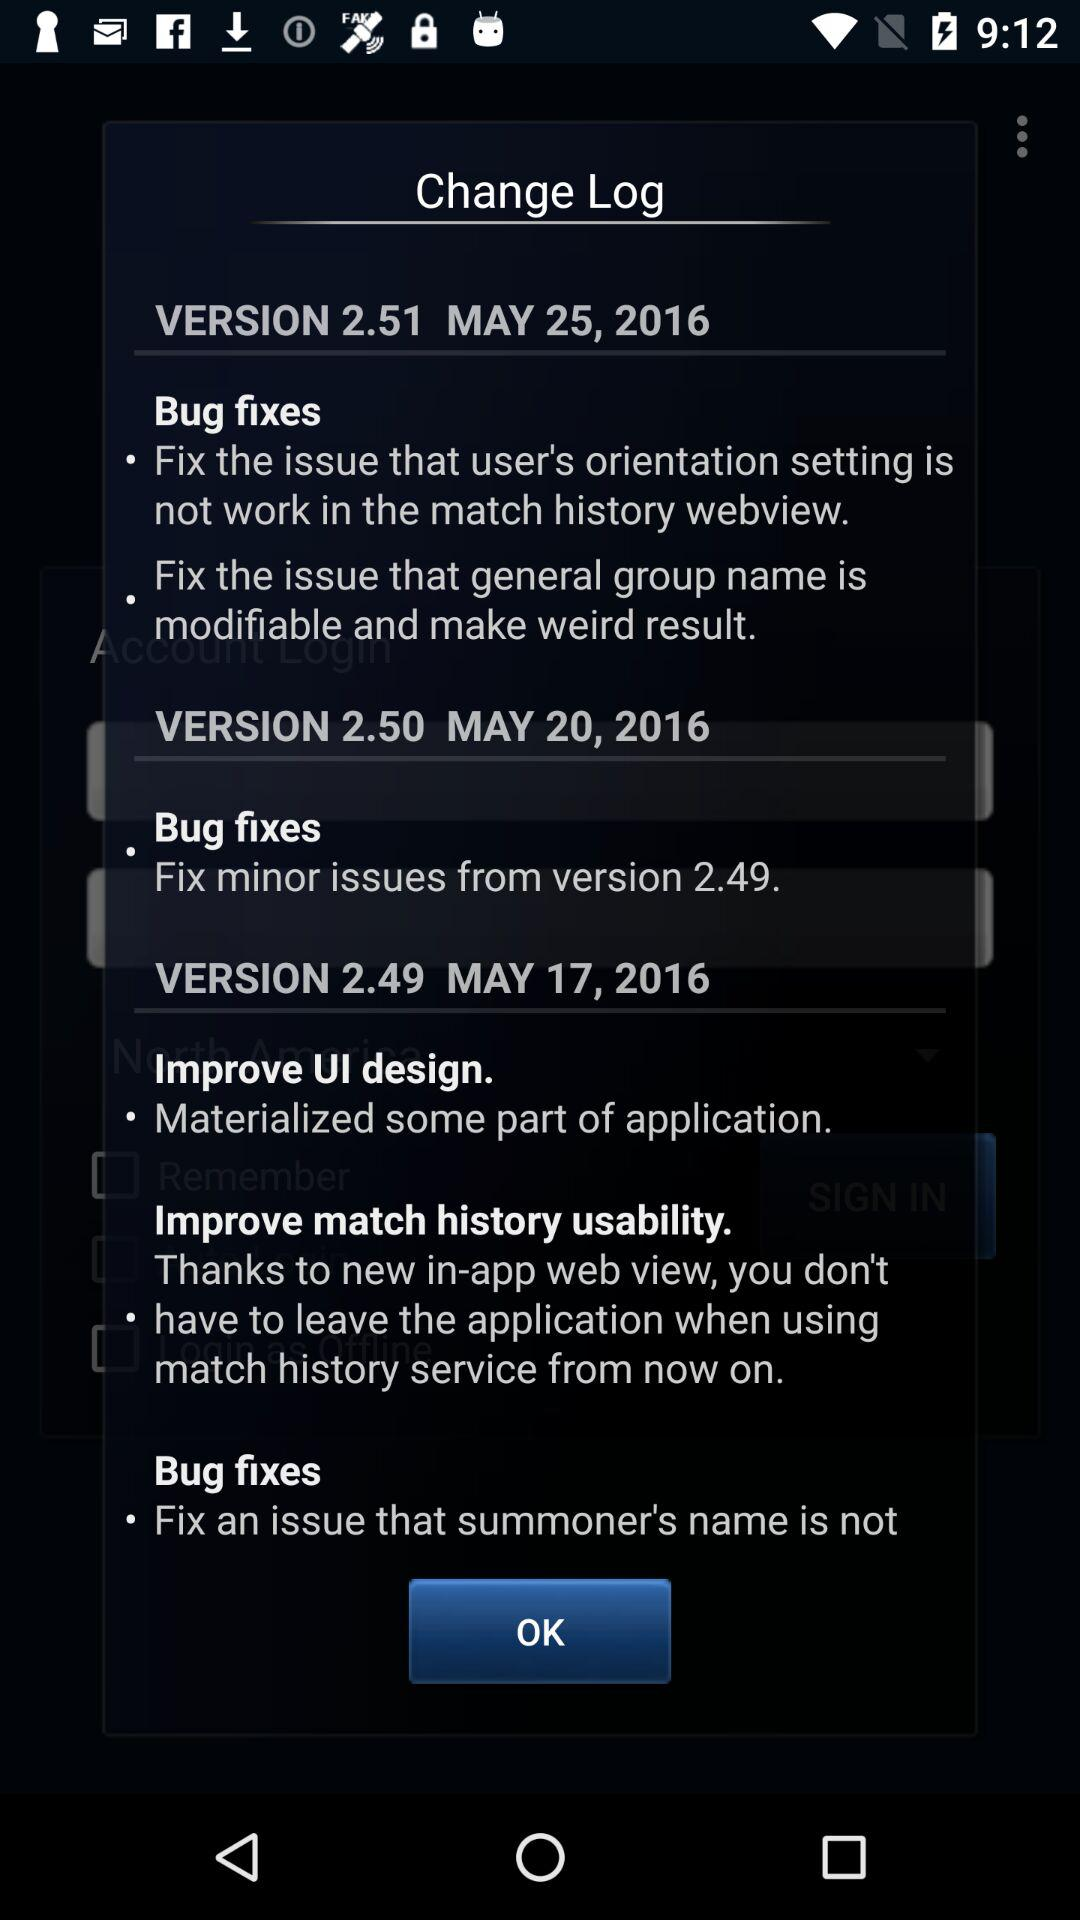Which version is updated on 20 may 2016? The updated version is 2.50. 